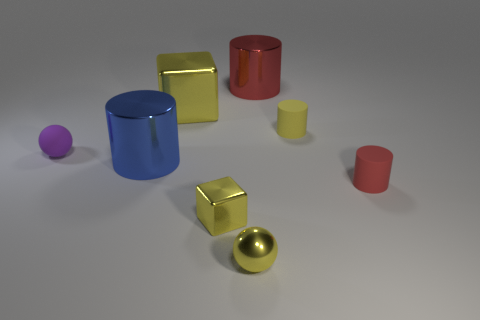There is a cylinder that is the same color as the tiny metal block; what is it made of?
Ensure brevity in your answer.  Rubber. There is a yellow object that is in front of the tiny yellow metal block; does it have the same shape as the red thing that is in front of the large cube?
Make the answer very short. No. There is a block that is the same size as the red matte object; what is its material?
Offer a terse response. Metal. Is the small yellow thing that is right of the tiny yellow metallic ball made of the same material as the large cylinder that is behind the large blue object?
Provide a short and direct response. No. What is the shape of the yellow metallic object that is the same size as the yellow sphere?
Provide a short and direct response. Cube. How many other things are there of the same color as the small metallic block?
Ensure brevity in your answer.  3. What is the color of the big metal cylinder that is in front of the yellow cylinder?
Make the answer very short. Blue. What number of other things are made of the same material as the yellow cylinder?
Provide a succinct answer. 2. Are there more large red cylinders on the left side of the big red metal object than metallic cylinders that are behind the large blue shiny object?
Your answer should be compact. No. There is a large blue cylinder; what number of metal cubes are behind it?
Keep it short and to the point. 1. 